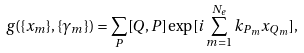Convert formula to latex. <formula><loc_0><loc_0><loc_500><loc_500>g ( \{ x _ { m } \} , \{ \gamma _ { m } \} ) = \sum _ { P } [ Q , P ] \exp [ i \sum _ { m = 1 } ^ { N _ { e } } k _ { P _ { m } } x _ { Q _ { m } } ] ,</formula> 